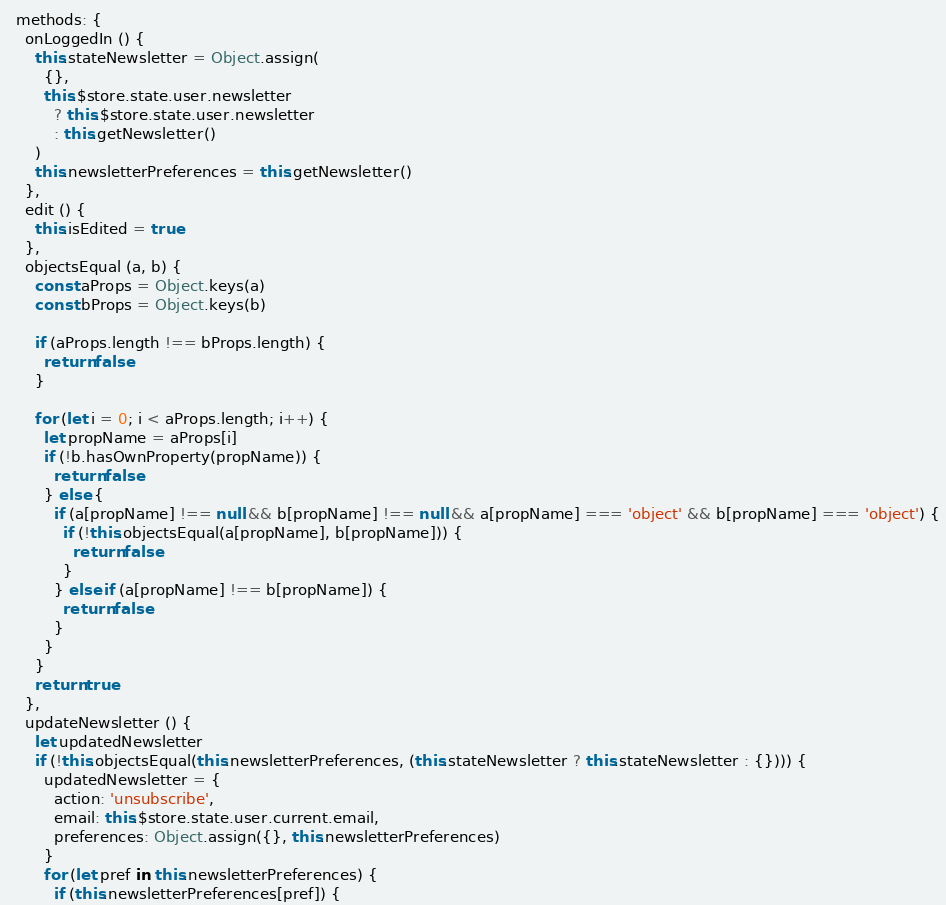<code> <loc_0><loc_0><loc_500><loc_500><_JavaScript_>  methods: {
    onLoggedIn () {
      this.stateNewsletter = Object.assign(
        {},
        this.$store.state.user.newsletter
          ? this.$store.state.user.newsletter
          : this.getNewsletter()
      )
      this.newsletterPreferences = this.getNewsletter()
    },
    edit () {
      this.isEdited = true
    },
    objectsEqual (a, b) {
      const aProps = Object.keys(a)
      const bProps = Object.keys(b)

      if (aProps.length !== bProps.length) {
        return false
      }

      for (let i = 0; i < aProps.length; i++) {
        let propName = aProps[i]
        if (!b.hasOwnProperty(propName)) {
          return false
        } else {
          if (a[propName] !== null && b[propName] !== null && a[propName] === 'object' && b[propName] === 'object') {
            if (!this.objectsEqual(a[propName], b[propName])) {
              return false
            }
          } else if (a[propName] !== b[propName]) {
            return false
          }
        }
      }
      return true
    },
    updateNewsletter () {
      let updatedNewsletter
      if (!this.objectsEqual(this.newsletterPreferences, (this.stateNewsletter ? this.stateNewsletter : {}))) {
        updatedNewsletter = {
          action: 'unsubscribe',
          email: this.$store.state.user.current.email,
          preferences: Object.assign({}, this.newsletterPreferences)
        }
        for (let pref in this.newsletterPreferences) {
          if (this.newsletterPreferences[pref]) {</code> 